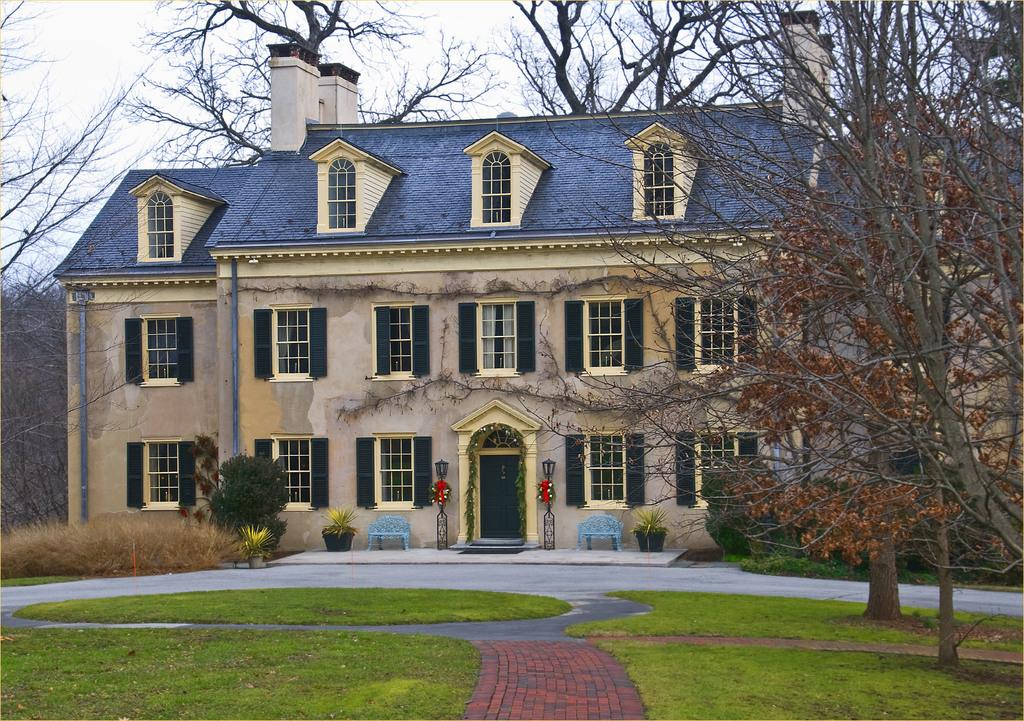What type of vegetation is present in the image? There is grass, plants in pots, and trees in the image. What type of structure is visible in the image? There is a building in the image. What part of the building can be seen in the image? Windows are visible in the image. What type of seating is present in the image? There are blue-colored benches in the image. What type of cave can be seen in the image? There is no cave present in the image. What sound can be heard coming from the bedroom in the image? There is no bedroom present in the image, so it's not possible to determine what sound might be heard. 